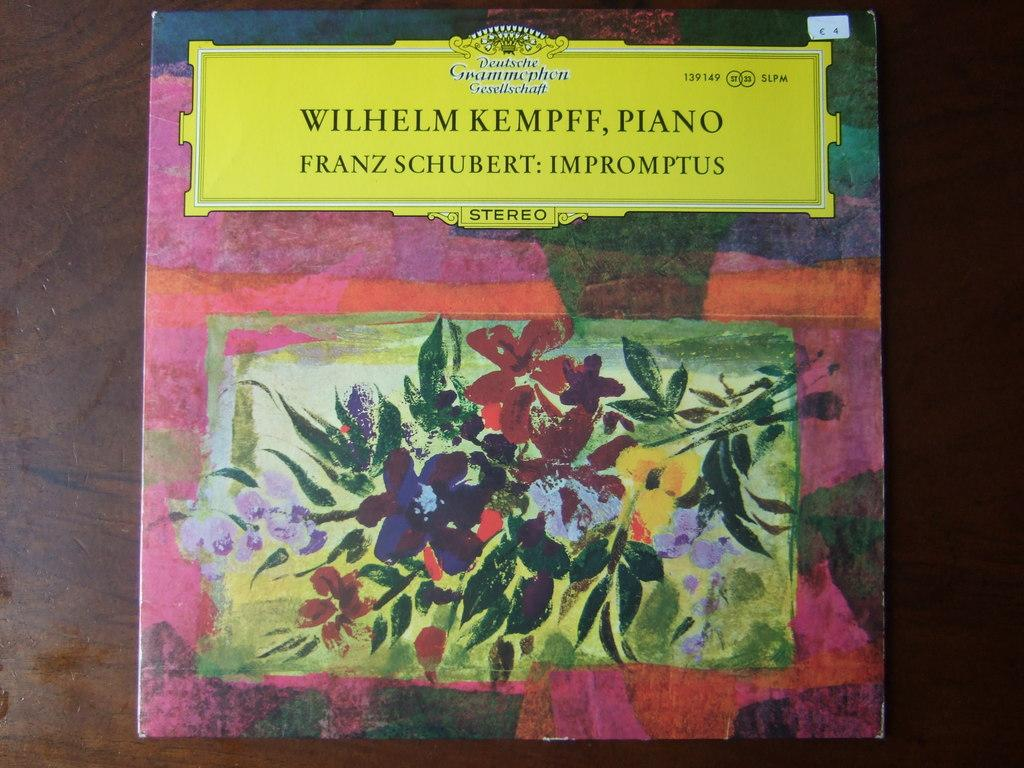Provide a one-sentence caption for the provided image. an album of Franz Schubert: Imptromptus sitting on a table. 